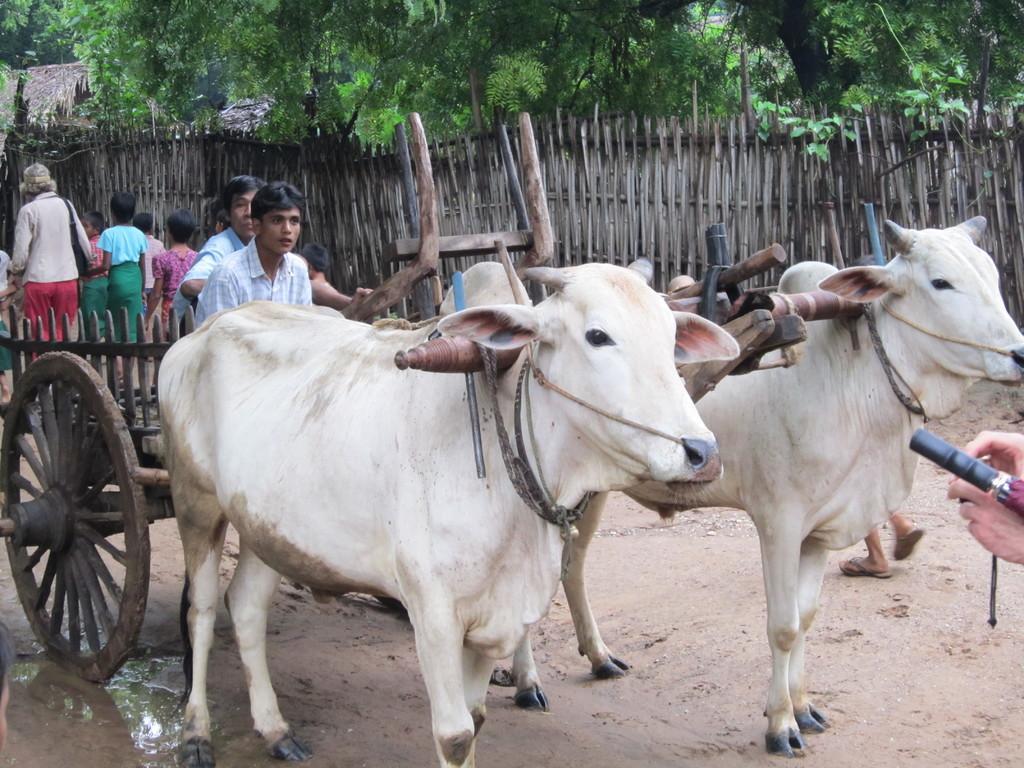How would you summarize this image in a sentence or two? In this picture we can see a bullock cart on the ground, here we can see people and in the background we can see a fence, trees, huts. 